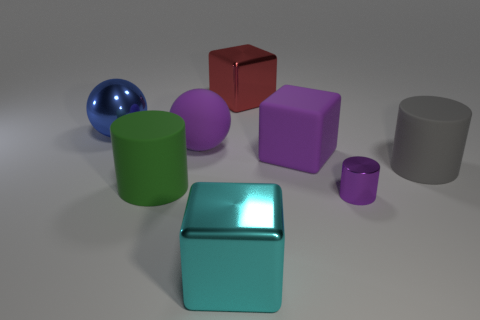Is there anything else that is the same size as the metallic cylinder?
Ensure brevity in your answer.  No. Are there any other things of the same color as the small cylinder?
Ensure brevity in your answer.  Yes. Is the color of the rubber sphere the same as the large rubber cube that is in front of the blue shiny ball?
Make the answer very short. Yes. What is the size of the matte thing that is the same color as the matte ball?
Provide a short and direct response. Large. The rubber cylinder that is the same size as the gray matte object is what color?
Keep it short and to the point. Green. What number of objects are either big cylinders on the right side of the big purple matte block or large objects?
Provide a succinct answer. 7. There is a small metal object that is the same color as the big matte cube; what is its shape?
Give a very brief answer. Cylinder. The big ball that is to the left of the large cylinder on the left side of the purple ball is made of what material?
Your response must be concise. Metal. Is there a gray cylinder that has the same material as the green object?
Your answer should be very brief. Yes. There is a metal thing behind the metal sphere; is there a small purple thing that is behind it?
Offer a very short reply. No. 